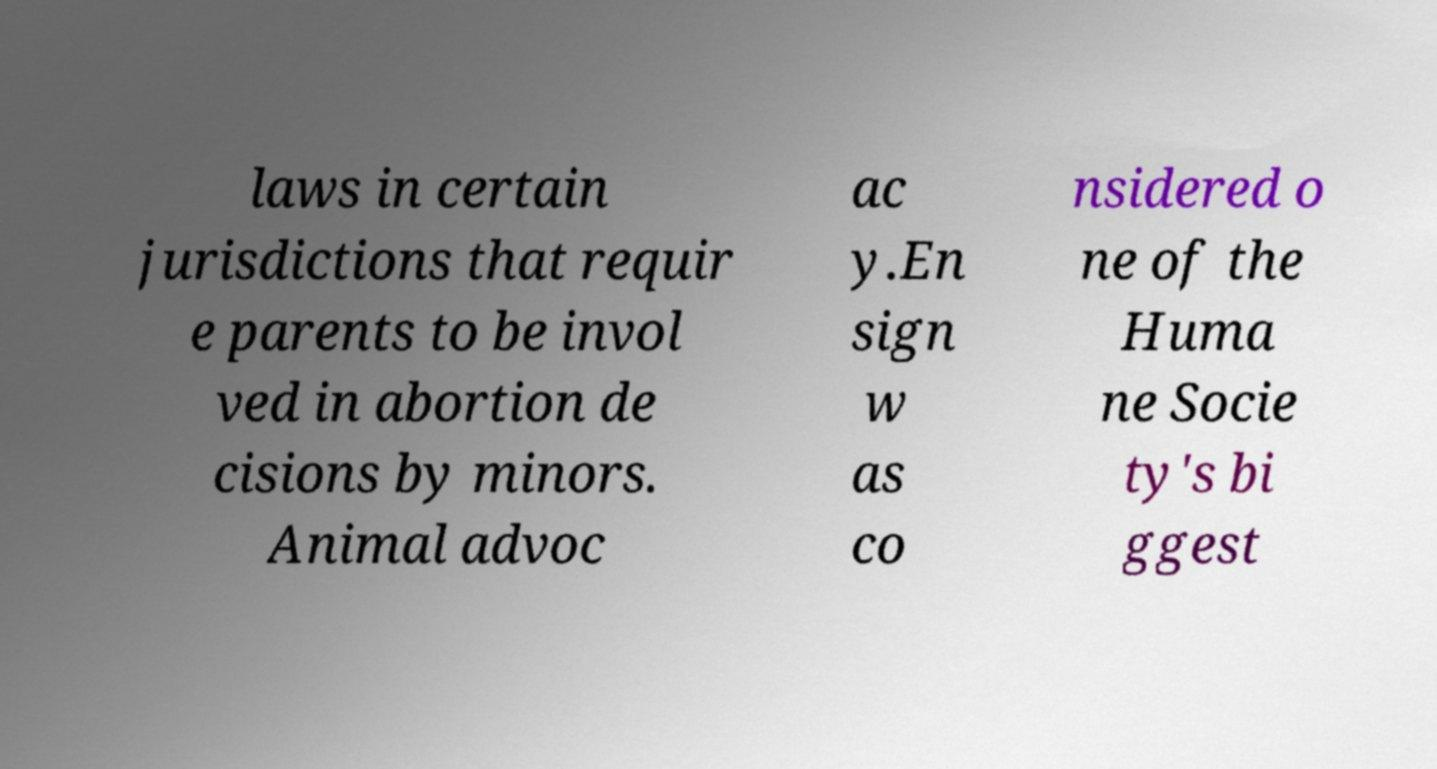Can you read and provide the text displayed in the image?This photo seems to have some interesting text. Can you extract and type it out for me? laws in certain jurisdictions that requir e parents to be invol ved in abortion de cisions by minors. Animal advoc ac y.En sign w as co nsidered o ne of the Huma ne Socie ty's bi ggest 